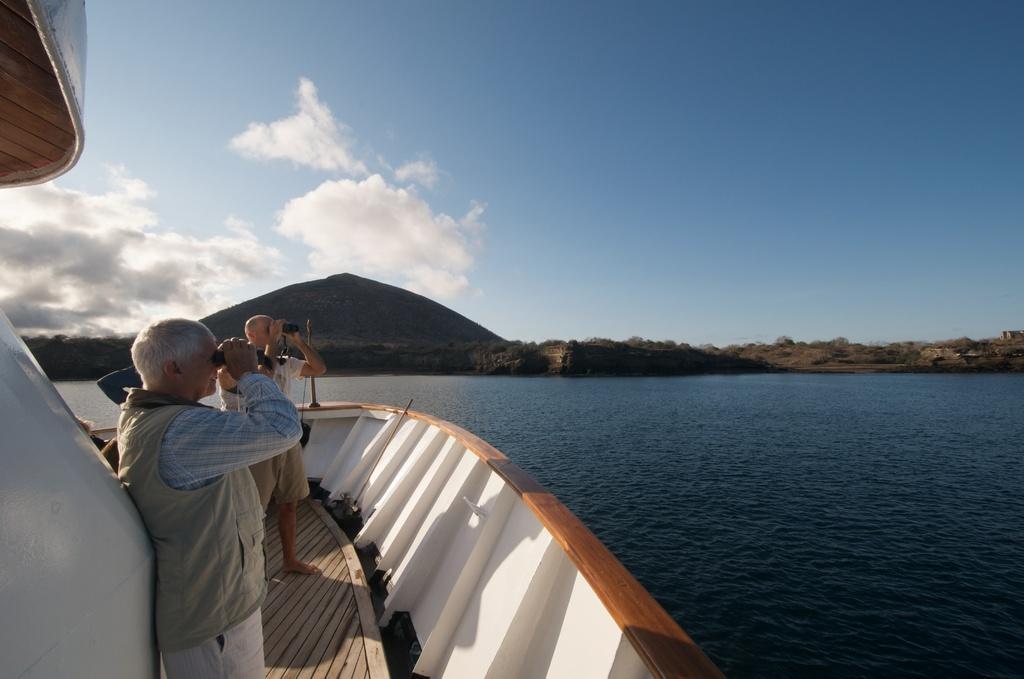Can you describe this image briefly? In this image I can see few people and two people are holding something. They are in the ship. I can see mountains, trees and the water. The sky is in blue color. 